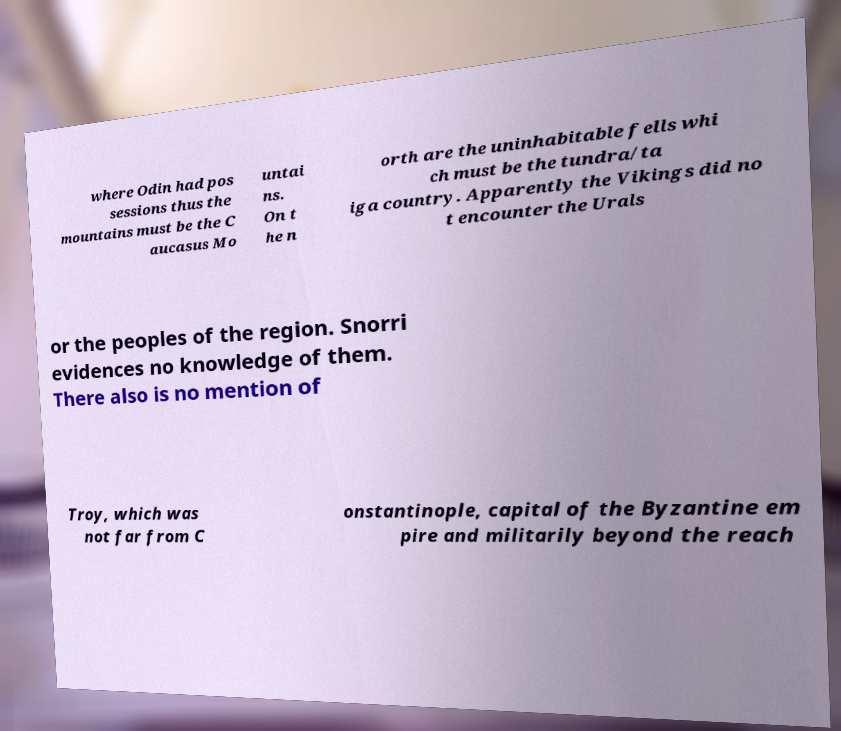Please read and relay the text visible in this image. What does it say? where Odin had pos sessions thus the mountains must be the C aucasus Mo untai ns. On t he n orth are the uninhabitable fells whi ch must be the tundra/ta iga country. Apparently the Vikings did no t encounter the Urals or the peoples of the region. Snorri evidences no knowledge of them. There also is no mention of Troy, which was not far from C onstantinople, capital of the Byzantine em pire and militarily beyond the reach 